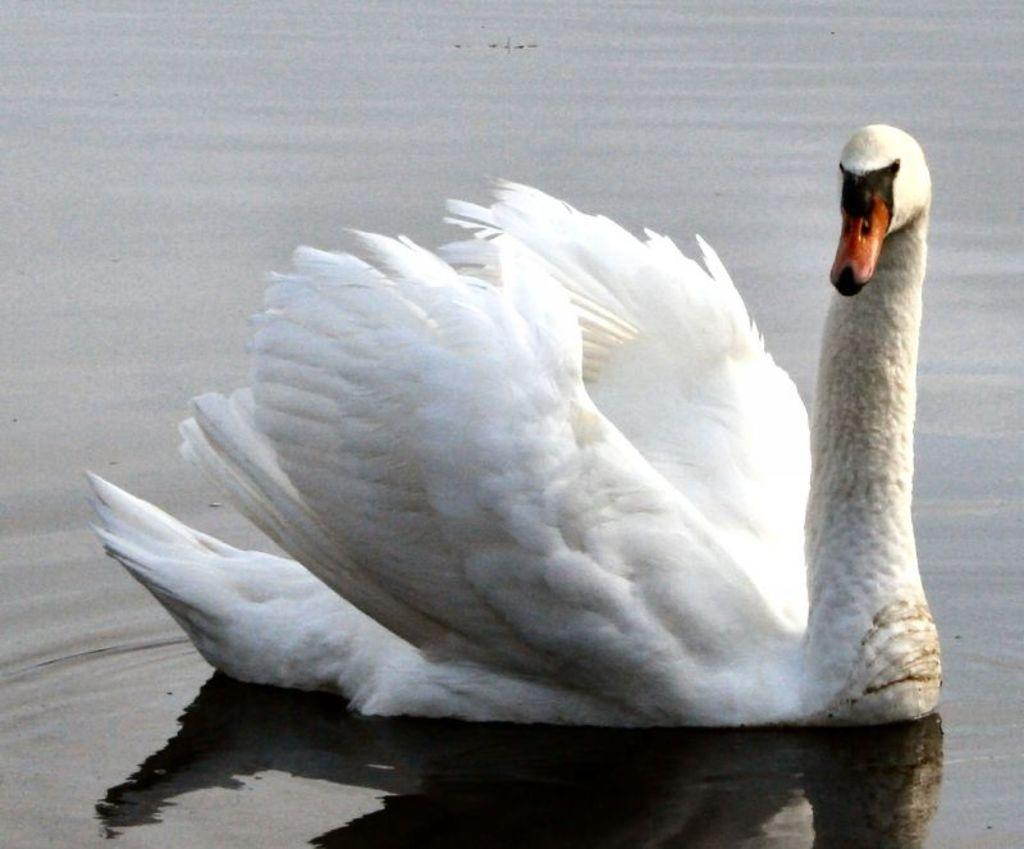Where was the image taken? The image is taken outdoors. What can be seen at the bottom of the image? There is a pond with water at the bottom of the image. What is in the pond? There is a swan in the pond. What color is the swan? The swan is white in color. What type of cabbage is growing near the pond in the image? There is no cabbage present in the image; it features a pond with a white swan. 